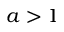Convert formula to latex. <formula><loc_0><loc_0><loc_500><loc_500>a > 1</formula> 